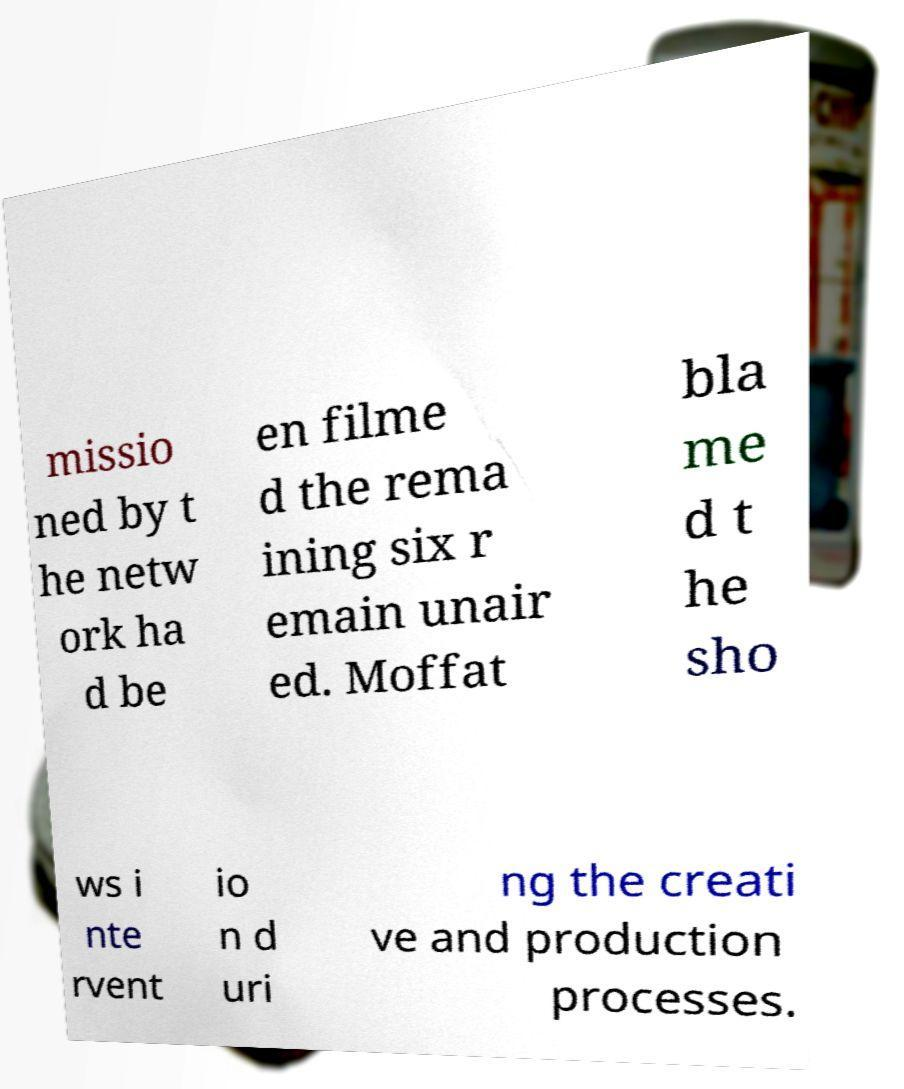I need the written content from this picture converted into text. Can you do that? missio ned by t he netw ork ha d be en filme d the rema ining six r emain unair ed. Moffat bla me d t he sho ws i nte rvent io n d uri ng the creati ve and production processes. 